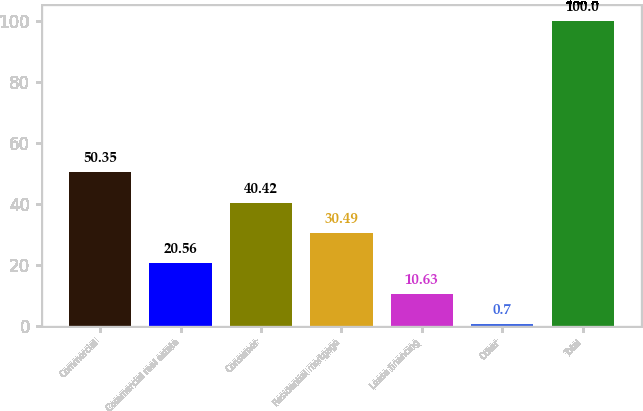Convert chart. <chart><loc_0><loc_0><loc_500><loc_500><bar_chart><fcel>Commercial<fcel>Commercial real estate<fcel>Consumer<fcel>Residential mortgage<fcel>Lease financing<fcel>Other<fcel>Total<nl><fcel>50.35<fcel>20.56<fcel>40.42<fcel>30.49<fcel>10.63<fcel>0.7<fcel>100<nl></chart> 